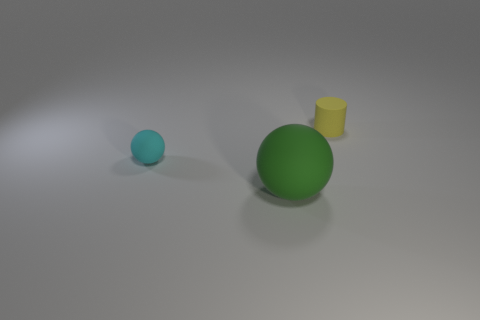What number of other things are the same color as the small cylinder? There is 1 object that is the same color as the small cylinder, which is the large sphere. 